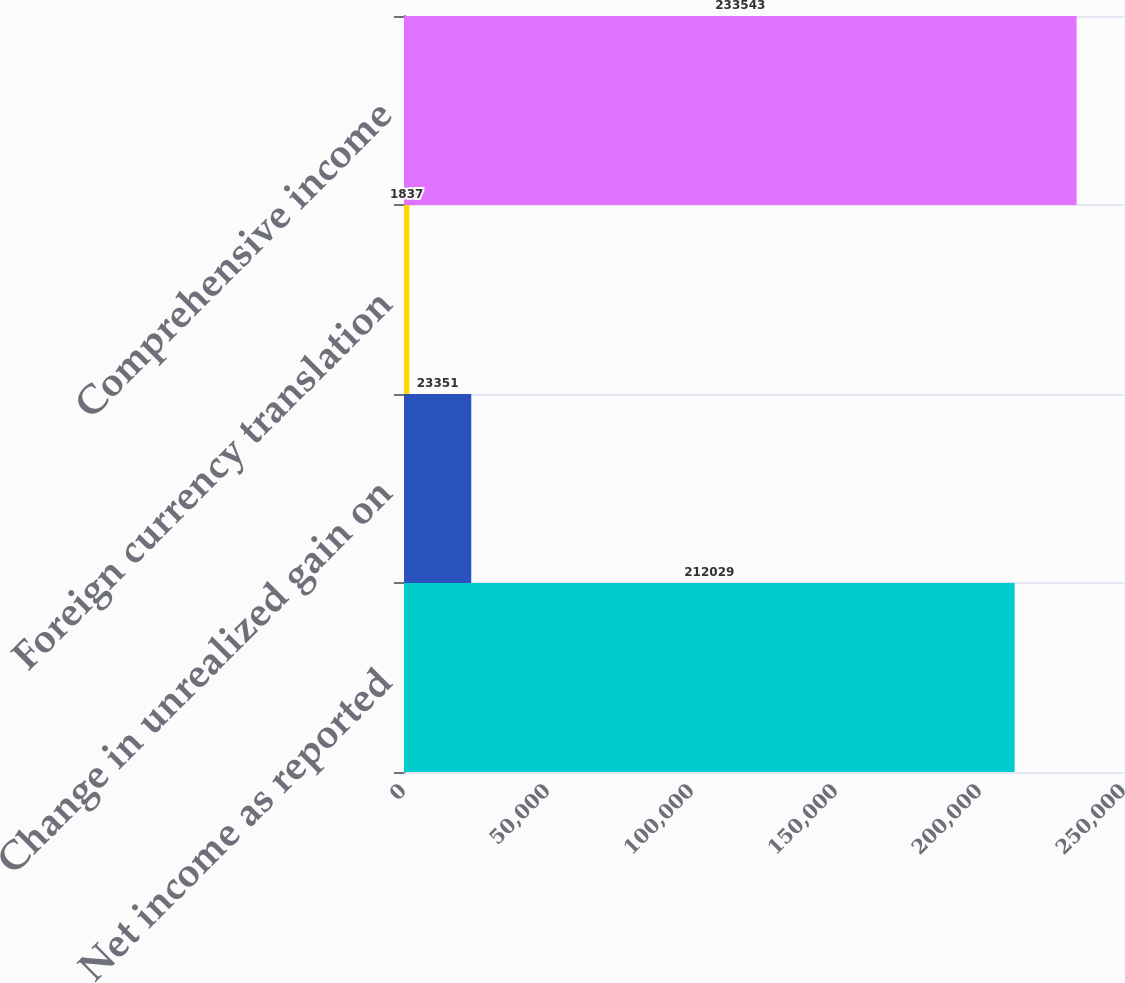<chart> <loc_0><loc_0><loc_500><loc_500><bar_chart><fcel>Net income as reported<fcel>Change in unrealized gain on<fcel>Foreign currency translation<fcel>Comprehensive income<nl><fcel>212029<fcel>23351<fcel>1837<fcel>233543<nl></chart> 